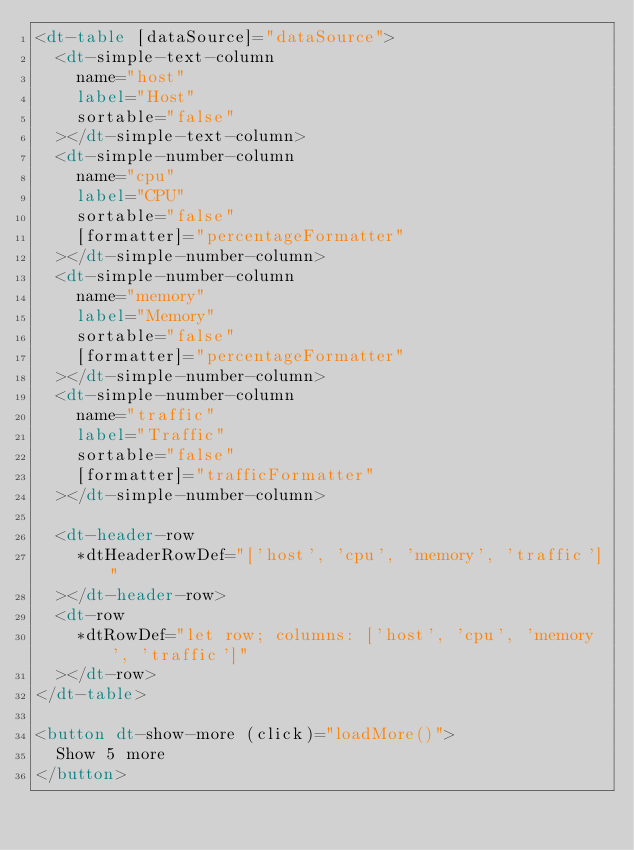<code> <loc_0><loc_0><loc_500><loc_500><_HTML_><dt-table [dataSource]="dataSource">
  <dt-simple-text-column
    name="host"
    label="Host"
    sortable="false"
  ></dt-simple-text-column>
  <dt-simple-number-column
    name="cpu"
    label="CPU"
    sortable="false"
    [formatter]="percentageFormatter"
  ></dt-simple-number-column>
  <dt-simple-number-column
    name="memory"
    label="Memory"
    sortable="false"
    [formatter]="percentageFormatter"
  ></dt-simple-number-column>
  <dt-simple-number-column
    name="traffic"
    label="Traffic"
    sortable="false"
    [formatter]="trafficFormatter"
  ></dt-simple-number-column>

  <dt-header-row
    *dtHeaderRowDef="['host', 'cpu', 'memory', 'traffic']"
  ></dt-header-row>
  <dt-row
    *dtRowDef="let row; columns: ['host', 'cpu', 'memory', 'traffic']"
  ></dt-row>
</dt-table>

<button dt-show-more (click)="loadMore()">
  Show 5 more
</button>
</code> 